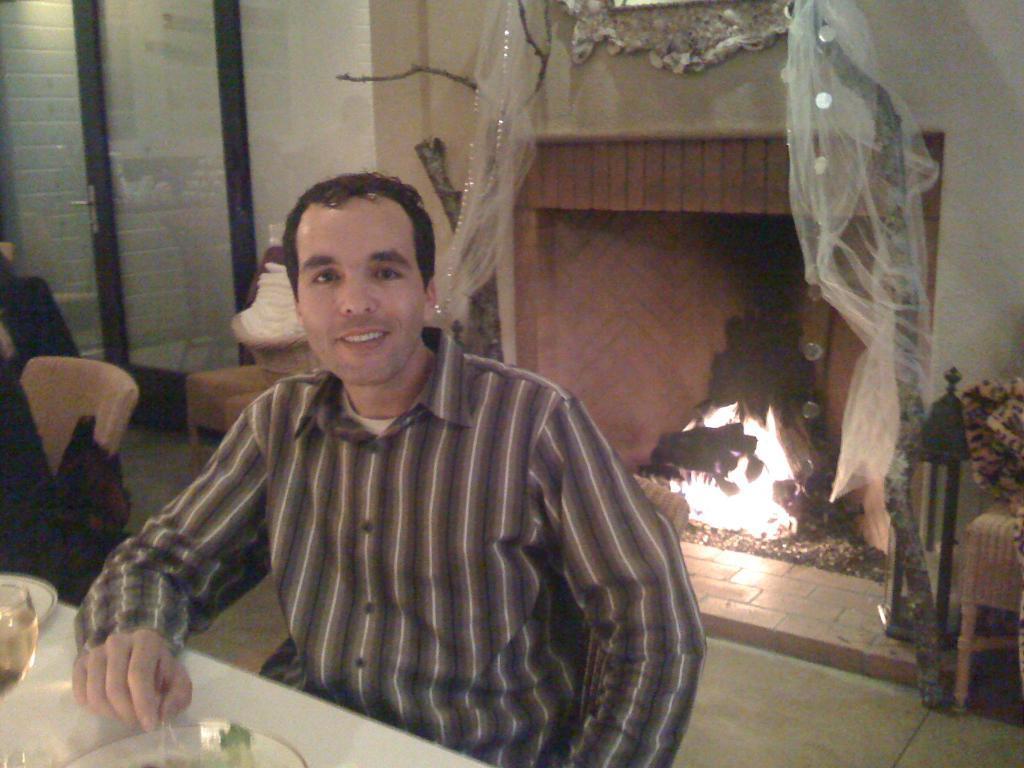In one or two sentences, can you explain what this image depicts? In the picture I can see a man is sitting in front of a table. On the table I can see a glass and some other objects. In the background I can see a fire place, the fire, a wall which has some objects attached to it, a glass door and some other objects. 